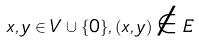<formula> <loc_0><loc_0><loc_500><loc_500>x , y \in V \cup \{ 0 \} , ( x , y ) \notin E</formula> 